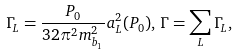Convert formula to latex. <formula><loc_0><loc_0><loc_500><loc_500>\Gamma _ { L } = \frac { P _ { 0 } } { 3 2 \pi ^ { 2 } m ^ { 2 } _ { b _ { 1 } } } a ^ { 2 } _ { L } ( P _ { 0 } ) , \, \Gamma = \sum _ { L } \Gamma _ { L } ,</formula> 